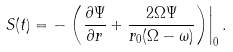Convert formula to latex. <formula><loc_0><loc_0><loc_500><loc_500>S ( t ) = - \left . \left ( \frac { \partial \Psi } { \partial r } + \frac { 2 \Omega \Psi } { r _ { 0 } ( \Omega - \omega ) } \right ) \right | _ { 0 } .</formula> 